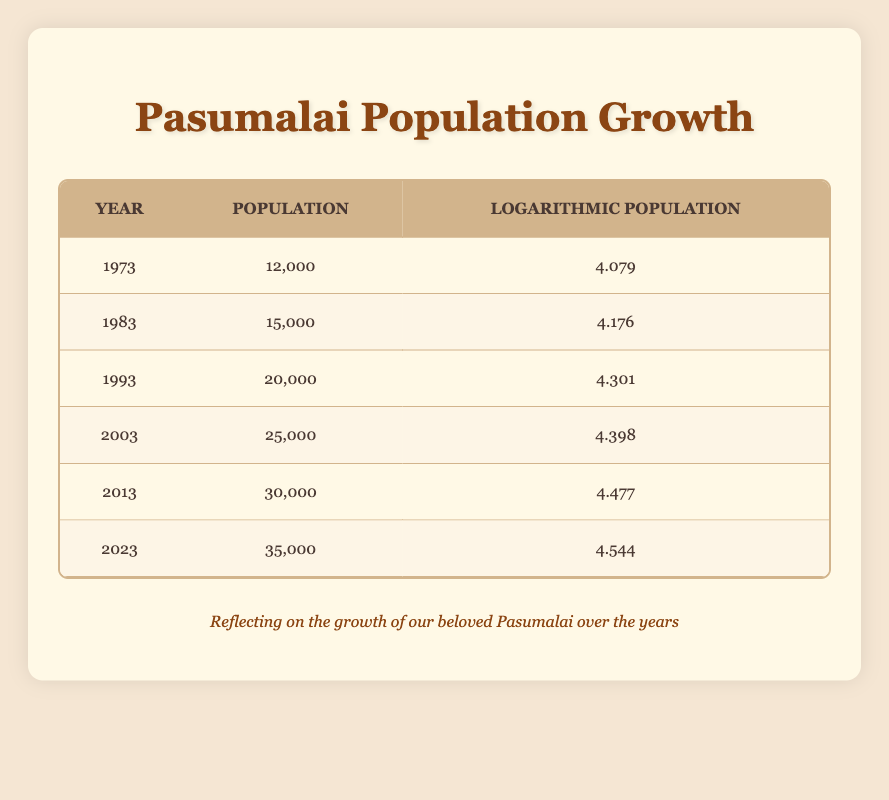What was the population of Pasumalai in the year 1993? The table shows that the population in 1993 was listed directly next to that year, which is 20,000.
Answer: 20,000 How much did the population increase from 1973 to 2023? The population in 1973 was 12,000 and in 2023 it was 35,000. The increase is calculated as 35,000 - 12,000 = 23,000.
Answer: 23,000 Is it true that the population of Pasumalai has increased by more than 10,000 in each decade shown? By examining the data: 1973 to 1983 is an increase of 3,000, 1983 to 1993 is 5,000, 1993 to 2003 is 5,000, and from 2003 to 2013 and 2013 to 2023, both are 5,000. None of these increases exceed 10,000, therefore the statement is false.
Answer: No What is the average logarithmic population from 1973 to 2023? The logarithmic populations are 4.079, 4.176, 4.301, 4.398, 4.477, and 4.544. To calculate the average, sum these values: 4.079 + 4.176 + 4.301 + 4.398 + 4.477 + 4.544 = 25.975. Divide by the number of years (6): 25.975 / 6 ≈ 4.329.
Answer: 4.329 In which decade did Pasumalai see the highest population growth? The population growth can be calculated per decade: 1973-1983 (3,000), 1983-1993 (5,000), 1993-2003 (5,000), 2003-2013 (5,000), and 2013-2023 (5,000). The largest growth was from 1973-1983, with an increase of 3,000, making it the lowest growth. The question is invalid as the growth was constant, from 1983 onwards.
Answer: No unique highest growth What is the logarithmic population for the year 2013? The table lists the logarithmic population directly under the year 2013 in the corresponding row, which is 4.477.
Answer: 4.477 Was the population of Pasumalai less than 30,000 in 2003? The population for 2003 is shown to be 25,000, which is less than 30,000, confirming the statement is true.
Answer: Yes What year showed the largest increase in population compared to the previous decade? Observing the increments: 1973 to 1983 (3,000), 1983 to 1993 (5,000), 1993 to 2003 (5,000), 2003 to 2013 (5,000), and 2013 to 2023 (5,000). The largest increase was from 1973 to 1983, indicating the decade exhibited the highest growth.
Answer: 1973 to 1983 